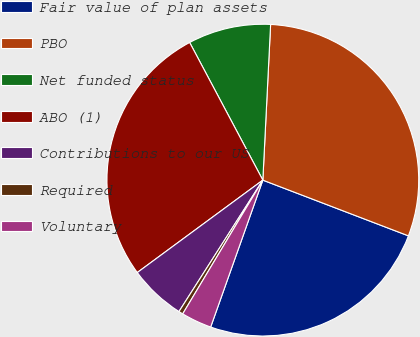<chart> <loc_0><loc_0><loc_500><loc_500><pie_chart><fcel>Fair value of plan assets<fcel>PBO<fcel>Net funded status<fcel>ABO (1)<fcel>Contributions to our US<fcel>Required<fcel>Voluntary<nl><fcel>24.61%<fcel>30.02%<fcel>8.57%<fcel>27.32%<fcel>5.86%<fcel>0.45%<fcel>3.16%<nl></chart> 